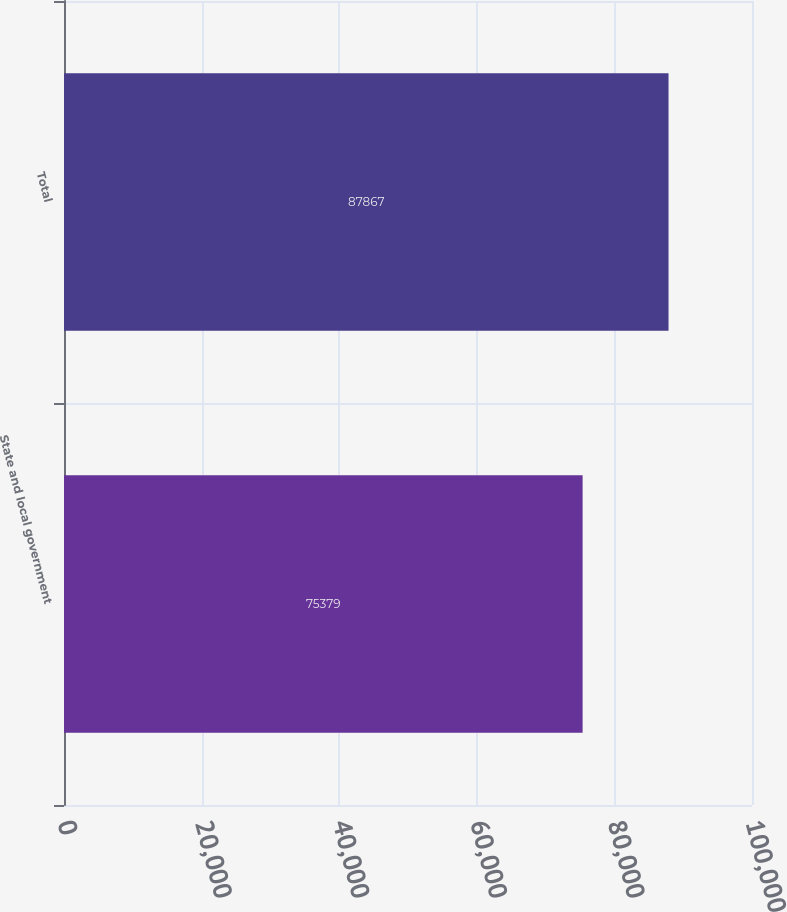Convert chart to OTSL. <chart><loc_0><loc_0><loc_500><loc_500><bar_chart><fcel>State and local government<fcel>Total<nl><fcel>75379<fcel>87867<nl></chart> 